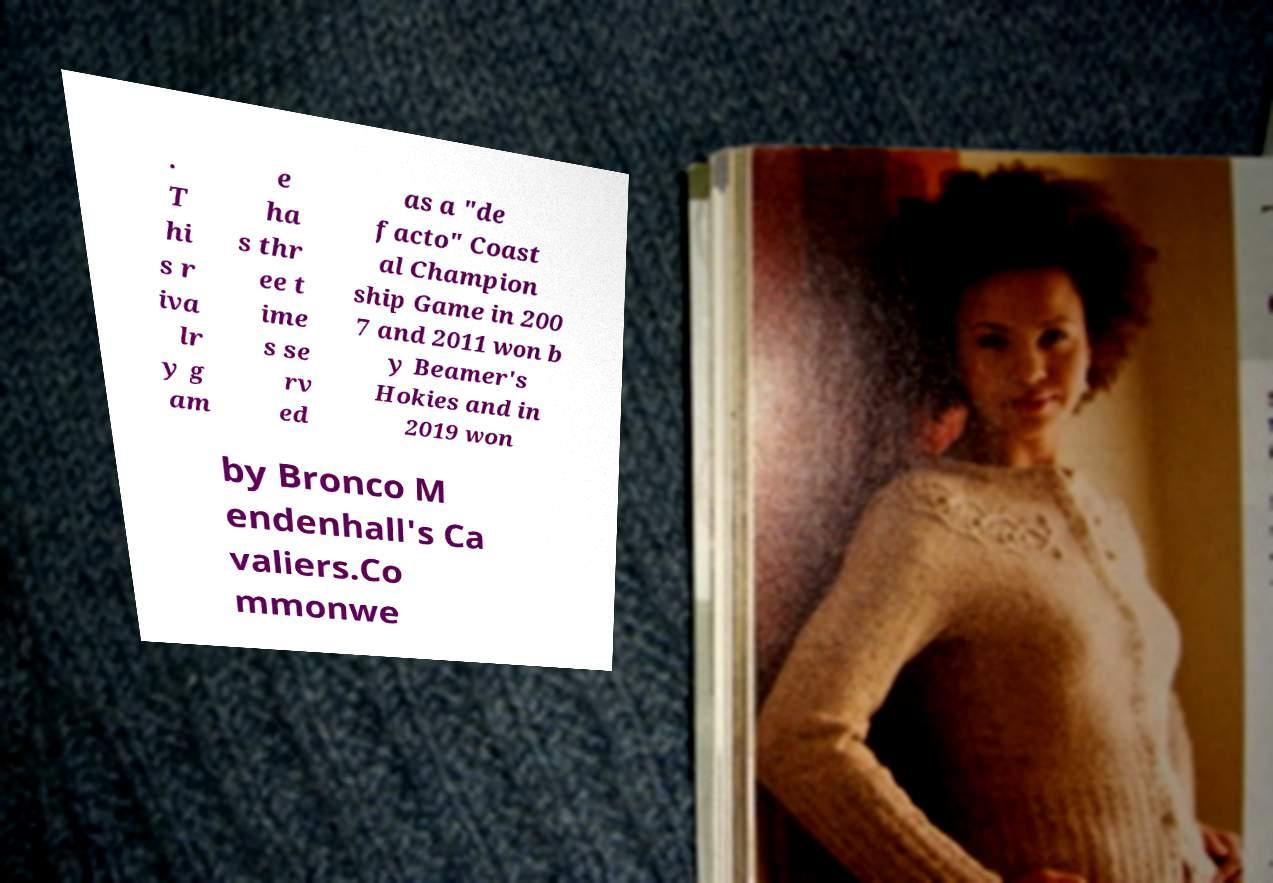Can you read and provide the text displayed in the image?This photo seems to have some interesting text. Can you extract and type it out for me? . T hi s r iva lr y g am e ha s thr ee t ime s se rv ed as a "de facto" Coast al Champion ship Game in 200 7 and 2011 won b y Beamer's Hokies and in 2019 won by Bronco M endenhall's Ca valiers.Co mmonwe 